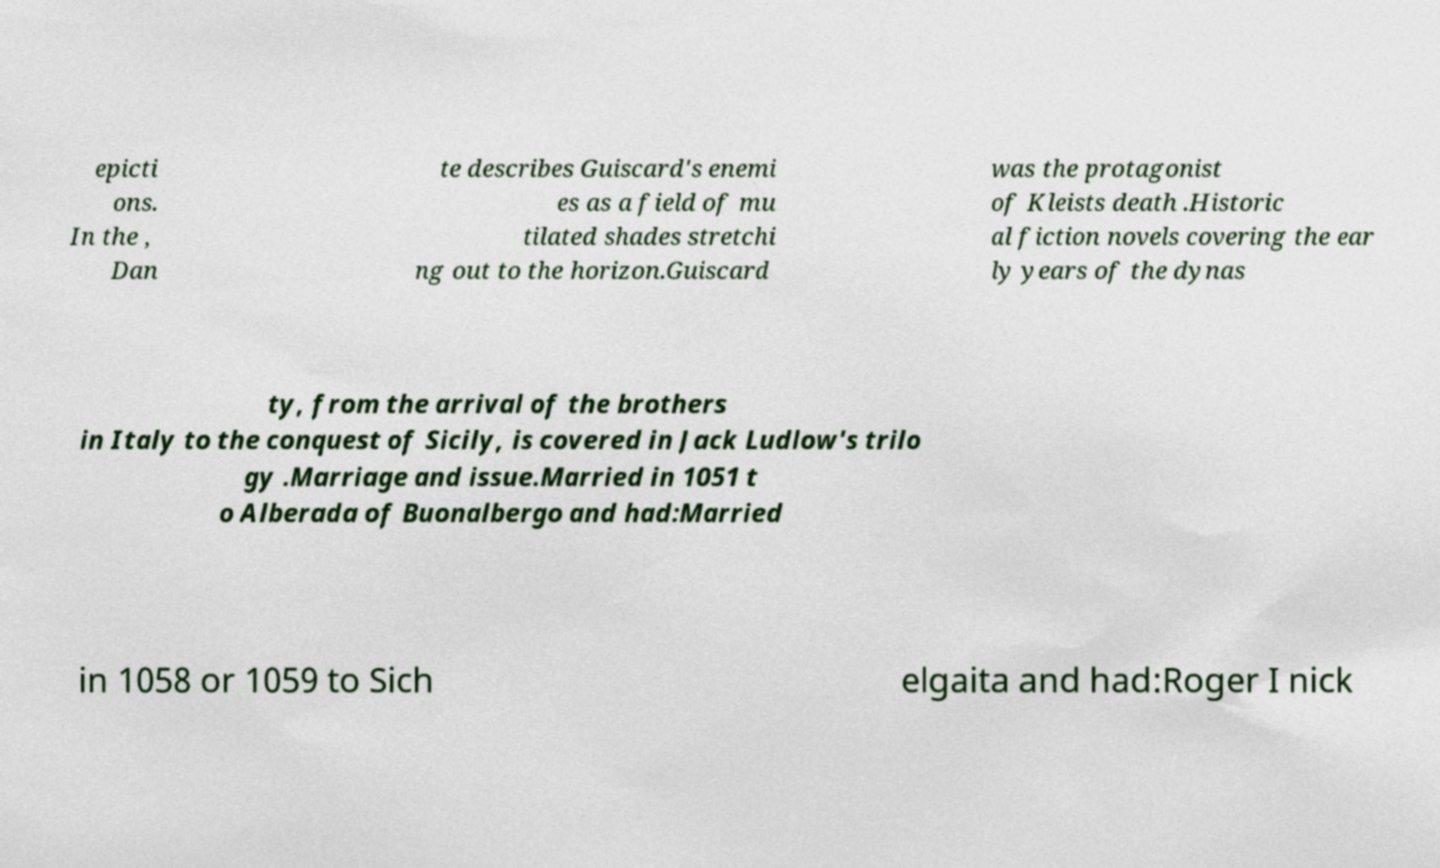Could you extract and type out the text from this image? epicti ons. In the , Dan te describes Guiscard's enemi es as a field of mu tilated shades stretchi ng out to the horizon.Guiscard was the protagonist of Kleists death .Historic al fiction novels covering the ear ly years of the dynas ty, from the arrival of the brothers in Italy to the conquest of Sicily, is covered in Jack Ludlow's trilo gy .Marriage and issue.Married in 1051 t o Alberada of Buonalbergo and had:Married in 1058 or 1059 to Sich elgaita and had:Roger I nick 